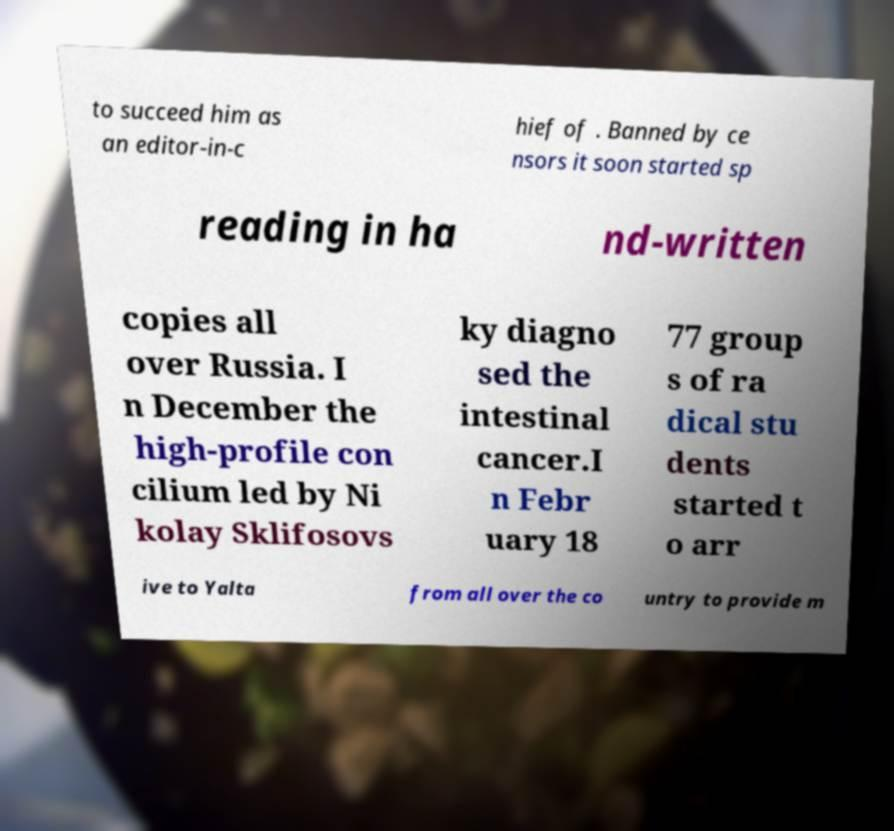Please read and relay the text visible in this image. What does it say? to succeed him as an editor-in-c hief of . Banned by ce nsors it soon started sp reading in ha nd-written copies all over Russia. I n December the high-profile con cilium led by Ni kolay Sklifosovs ky diagno sed the intestinal cancer.I n Febr uary 18 77 group s of ra dical stu dents started t o arr ive to Yalta from all over the co untry to provide m 